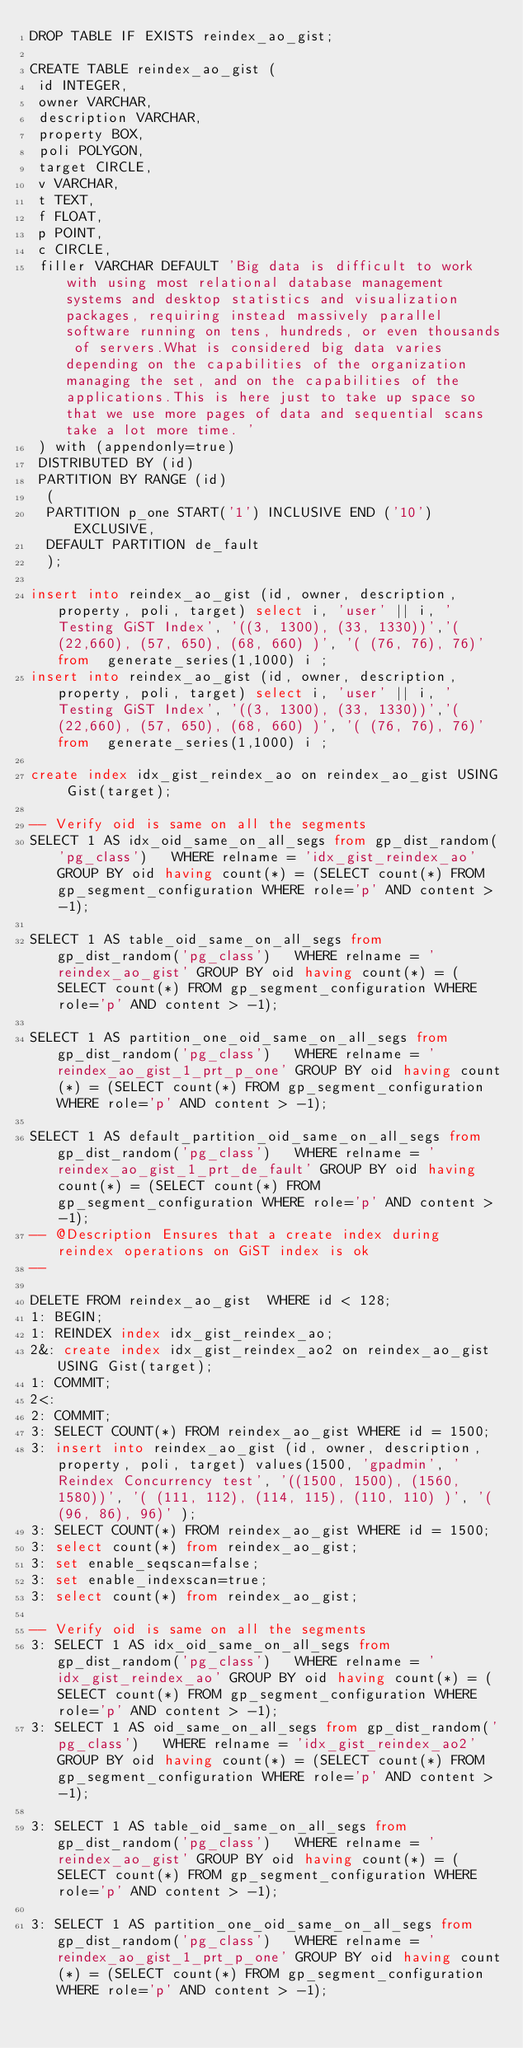Convert code to text. <code><loc_0><loc_0><loc_500><loc_500><_SQL_>DROP TABLE IF EXISTS reindex_ao_gist;

CREATE TABLE reindex_ao_gist (
 id INTEGER,
 owner VARCHAR,
 description VARCHAR,
 property BOX, 
 poli POLYGON,
 target CIRCLE,
 v VARCHAR,
 t TEXT,
 f FLOAT, 
 p POINT,
 c CIRCLE,
 filler VARCHAR DEFAULT 'Big data is difficult to work with using most relational database management systems and desktop statistics and visualization packages, requiring instead massively parallel software running on tens, hundreds, or even thousands of servers.What is considered big data varies depending on the capabilities of the organization managing the set, and on the capabilities of the applications.This is here just to take up space so that we use more pages of data and sequential scans take a lot more time. ' 
 ) with (appendonly=true) 
 DISTRIBUTED BY (id)
 PARTITION BY RANGE (id)
  (
  PARTITION p_one START('1') INCLUSIVE END ('10') EXCLUSIVE,
  DEFAULT PARTITION de_fault
  );

insert into reindex_ao_gist (id, owner, description, property, poli, target) select i, 'user' || i, 'Testing GiST Index', '((3, 1300), (33, 1330))','( (22,660), (57, 650), (68, 660) )', '( (76, 76), 76)' from  generate_series(1,1000) i ;
insert into reindex_ao_gist (id, owner, description, property, poli, target) select i, 'user' || i, 'Testing GiST Index', '((3, 1300), (33, 1330))','( (22,660), (57, 650), (68, 660) )', '( (76, 76), 76)' from  generate_series(1,1000) i ;

create index idx_gist_reindex_ao on reindex_ao_gist USING Gist(target);

-- Verify oid is same on all the segments
SELECT 1 AS idx_oid_same_on_all_segs from gp_dist_random('pg_class')   WHERE relname = 'idx_gist_reindex_ao' GROUP BY oid having count(*) = (SELECT count(*) FROM gp_segment_configuration WHERE role='p' AND content > -1);

SELECT 1 AS table_oid_same_on_all_segs from gp_dist_random('pg_class')   WHERE relname = 'reindex_ao_gist' GROUP BY oid having count(*) = (SELECT count(*) FROM gp_segment_configuration WHERE role='p' AND content > -1);

SELECT 1 AS partition_one_oid_same_on_all_segs from gp_dist_random('pg_class')   WHERE relname = 'reindex_ao_gist_1_prt_p_one' GROUP BY oid having count(*) = (SELECT count(*) FROM gp_segment_configuration WHERE role='p' AND content > -1);

SELECT 1 AS default_partition_oid_same_on_all_segs from gp_dist_random('pg_class')   WHERE relname = 'reindex_ao_gist_1_prt_de_fault' GROUP BY oid having count(*) = (SELECT count(*) FROM gp_segment_configuration WHERE role='p' AND content > -1);
-- @Description Ensures that a create index during reindex operations on GiST index is ok
-- 

DELETE FROM reindex_ao_gist  WHERE id < 128;
1: BEGIN;
1: REINDEX index idx_gist_reindex_ao;
2&: create index idx_gist_reindex_ao2 on reindex_ao_gist USING Gist(target);
1: COMMIT;
2<:
2: COMMIT;
3: SELECT COUNT(*) FROM reindex_ao_gist WHERE id = 1500;
3: insert into reindex_ao_gist (id, owner, description, property, poli, target) values(1500, 'gpadmin', 'Reindex Concurrency test', '((1500, 1500), (1560, 1580))', '( (111, 112), (114, 115), (110, 110) )', '( (96, 86), 96)' );
3: SELECT COUNT(*) FROM reindex_ao_gist WHERE id = 1500;
3: select count(*) from reindex_ao_gist;
3: set enable_seqscan=false;
3: set enable_indexscan=true;
3: select count(*) from reindex_ao_gist;

-- Verify oid is same on all the segments
3: SELECT 1 AS idx_oid_same_on_all_segs from gp_dist_random('pg_class')   WHERE relname = 'idx_gist_reindex_ao' GROUP BY oid having count(*) = (SELECT count(*) FROM gp_segment_configuration WHERE role='p' AND content > -1);
3: SELECT 1 AS oid_same_on_all_segs from gp_dist_random('pg_class')   WHERE relname = 'idx_gist_reindex_ao2' GROUP BY oid having count(*) = (SELECT count(*) FROM gp_segment_configuration WHERE role='p' AND content > -1);

3: SELECT 1 AS table_oid_same_on_all_segs from gp_dist_random('pg_class')   WHERE relname = 'reindex_ao_gist' GROUP BY oid having count(*) = (SELECT count(*) FROM gp_segment_configuration WHERE role='p' AND content > -1);

3: SELECT 1 AS partition_one_oid_same_on_all_segs from gp_dist_random('pg_class')   WHERE relname = 'reindex_ao_gist_1_prt_p_one' GROUP BY oid having count(*) = (SELECT count(*) FROM gp_segment_configuration WHERE role='p' AND content > -1);
</code> 